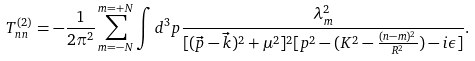<formula> <loc_0><loc_0><loc_500><loc_500>T _ { n n } ^ { ( 2 ) } = - \frac { 1 } { 2 \pi ^ { 2 } } \sum _ { m = - N } ^ { m = + N } \int d ^ { 3 } p \frac { \lambda _ { m } ^ { 2 } } { [ ( \vec { p } - \vec { k } ) ^ { 2 } + \mu ^ { 2 } ] ^ { 2 } [ p ^ { 2 } - ( K ^ { 2 } - \frac { ( n - m ) ^ { 2 } } { R ^ { 2 } } ) - i \epsilon ] } .</formula> 